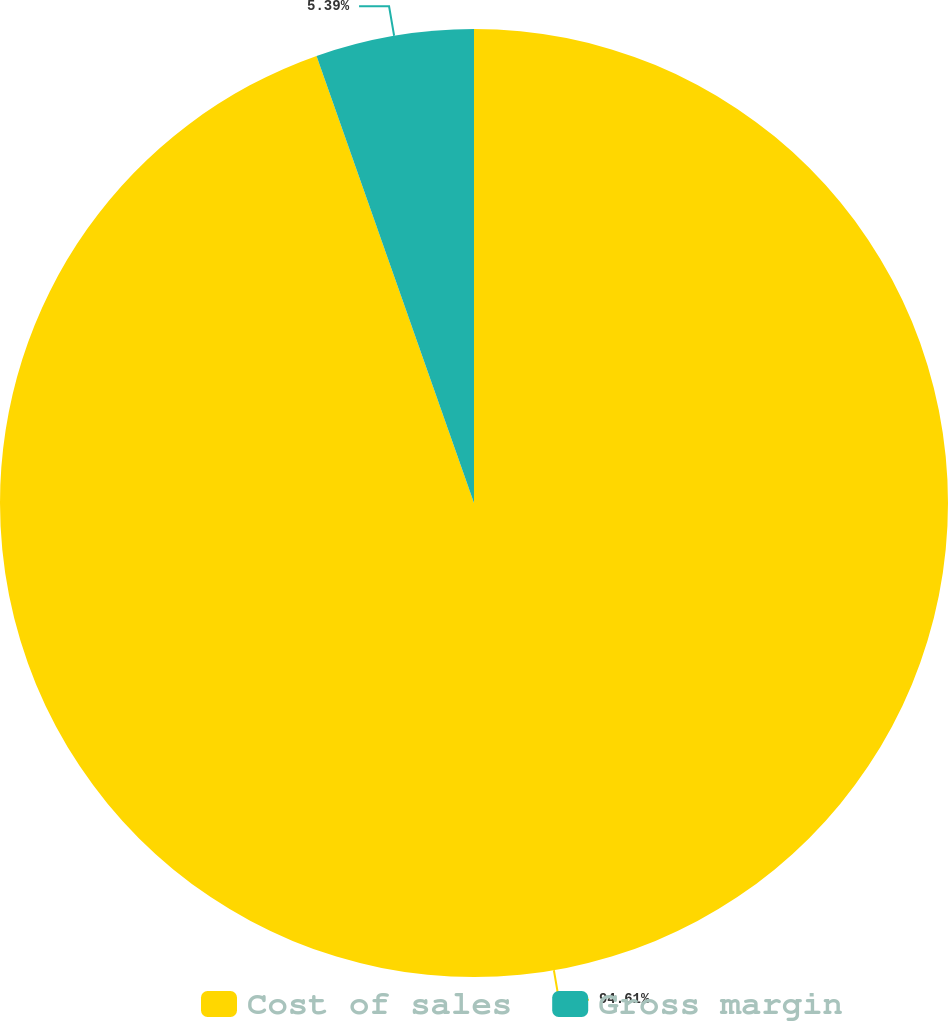<chart> <loc_0><loc_0><loc_500><loc_500><pie_chart><fcel>Cost of sales<fcel>Gross margin<nl><fcel>94.61%<fcel>5.39%<nl></chart> 